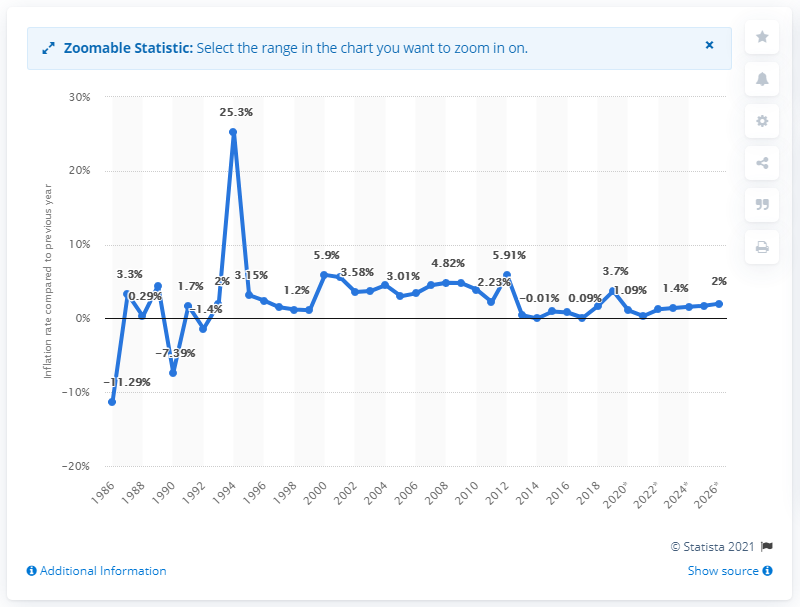Identify some key points in this picture. In 2019, the inflation rate in Comoros was 3.7%. 